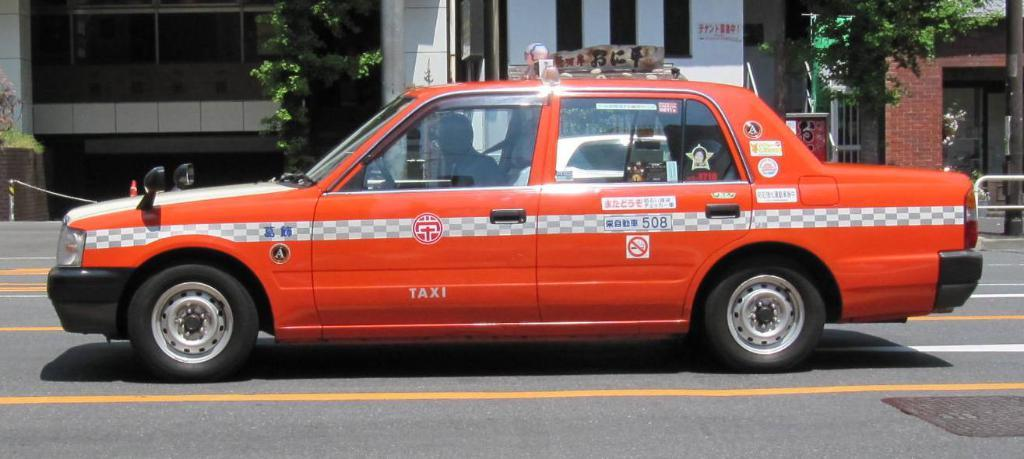What is the main subject of the image? The main subject of the image is a car. Can you describe the car's appearance? The car is orange in color. What can be seen in the background of the image? There are buildings and trees in the background of the image. What type of haircut does the pig have in the image? There is no pig present in the image, so it is not possible to answer that question. 